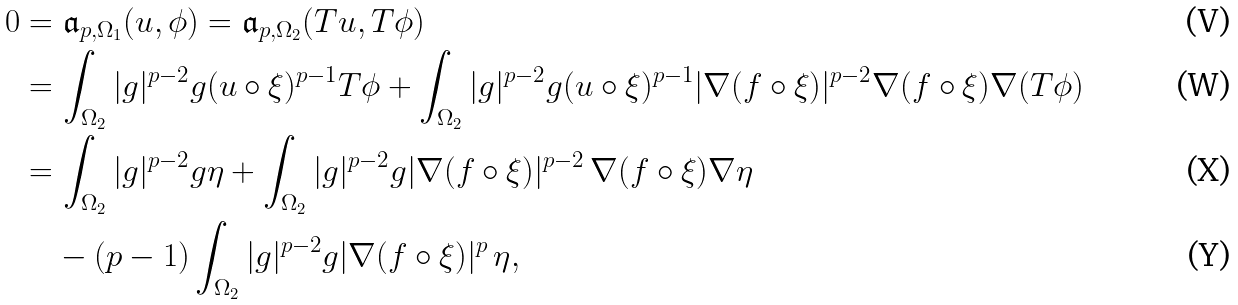<formula> <loc_0><loc_0><loc_500><loc_500>0 & = \mathfrak { a } _ { p , \Omega _ { 1 } } ( u , \phi ) = \mathfrak { a } _ { p , \Omega _ { 2 } } ( T u , T \phi ) \\ & = \int _ { \Omega _ { 2 } } | g | ^ { p - 2 } g ( u \circ \xi ) ^ { p - 1 } T \phi + \int _ { \Omega _ { 2 } } | g | ^ { p - 2 } g ( u \circ \xi ) ^ { p - 1 } | \nabla ( f \circ \xi ) | ^ { p - 2 } \nabla ( f \circ \xi ) \nabla ( T \phi ) \\ & = \int _ { \Omega _ { 2 } } | g | ^ { p - 2 } g \eta + \int _ { \Omega _ { 2 } } | g | ^ { p - 2 } g | \nabla ( f \circ \xi ) | ^ { p - 2 } \, \nabla ( f \circ \xi ) \nabla \eta \\ & \quad - ( p - 1 ) \int _ { \Omega _ { 2 } } | g | ^ { p - 2 } g | \nabla ( f \circ \xi ) | ^ { p } \, \eta ,</formula> 